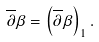<formula> <loc_0><loc_0><loc_500><loc_500>\overline { \partial } \beta = \left ( \overline { \partial } \beta \right ) _ { 1 } .</formula> 